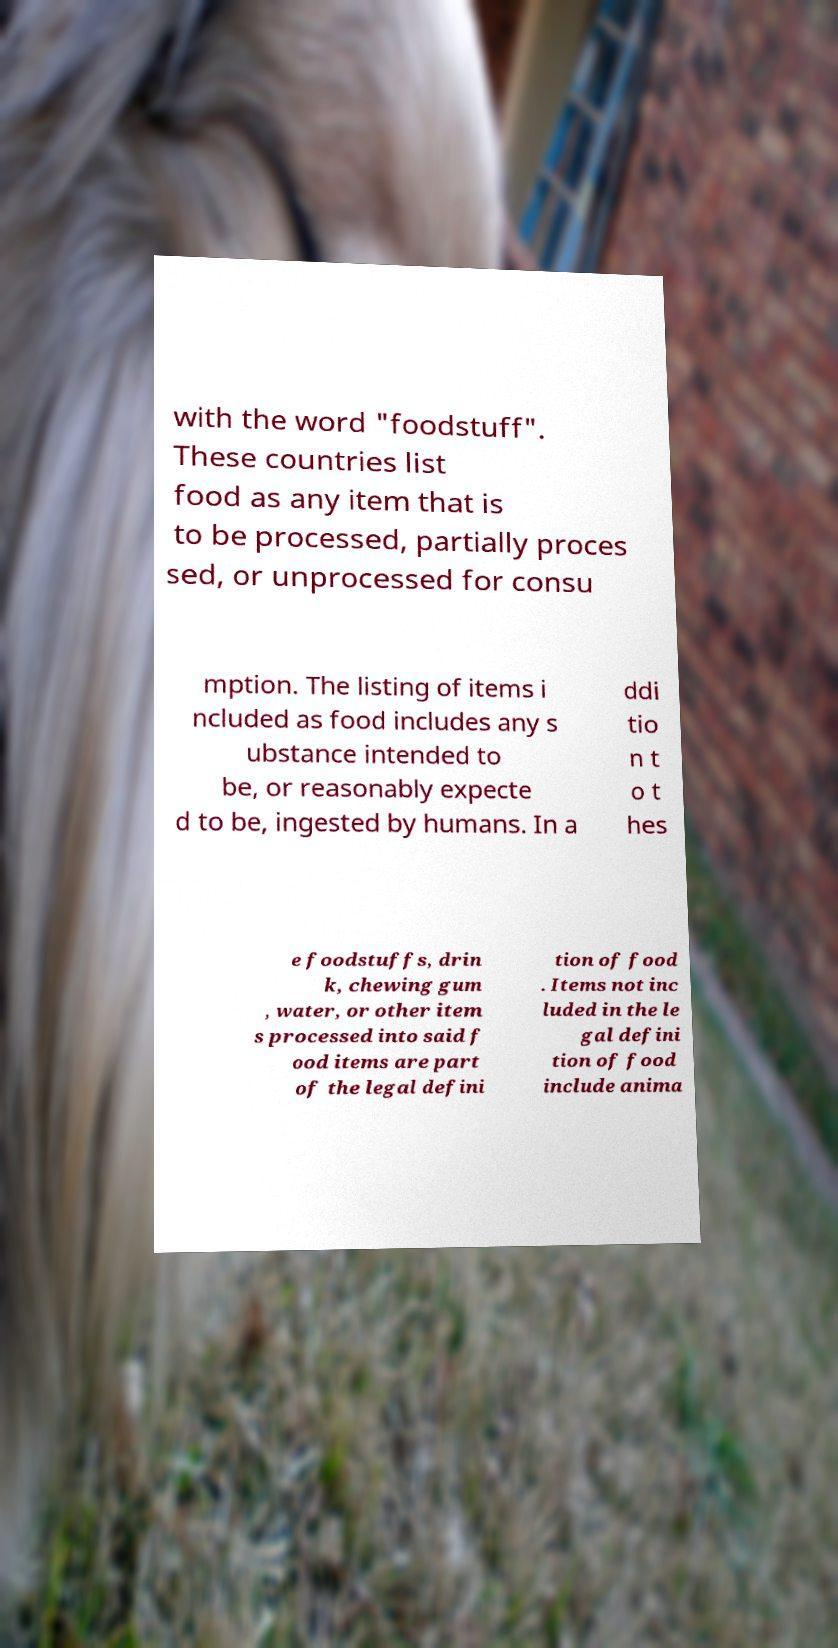Please identify and transcribe the text found in this image. with the word "foodstuff". These countries list food as any item that is to be processed, partially proces sed, or unprocessed for consu mption. The listing of items i ncluded as food includes any s ubstance intended to be, or reasonably expecte d to be, ingested by humans. In a ddi tio n t o t hes e foodstuffs, drin k, chewing gum , water, or other item s processed into said f ood items are part of the legal defini tion of food . Items not inc luded in the le gal defini tion of food include anima 